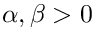<formula> <loc_0><loc_0><loc_500><loc_500>\alpha , \beta > 0</formula> 